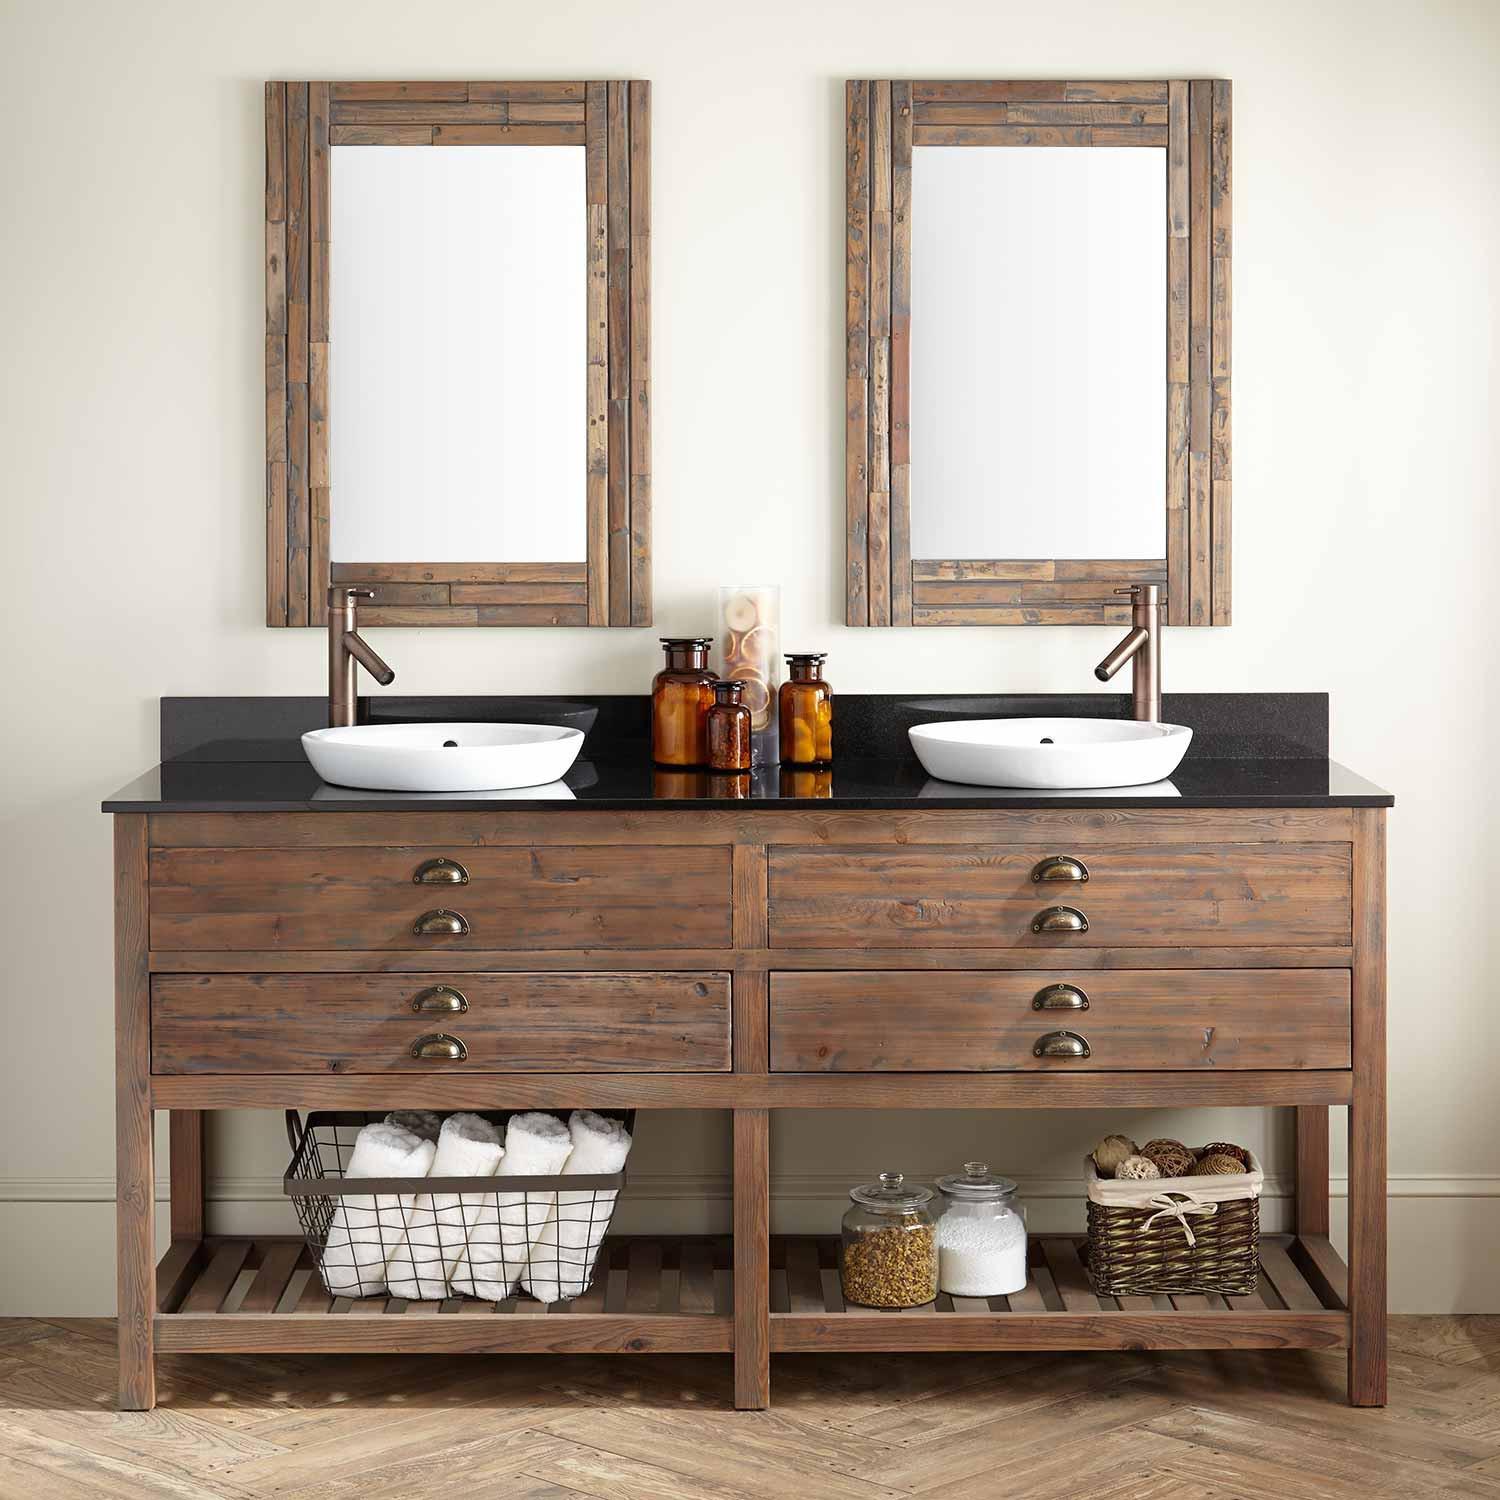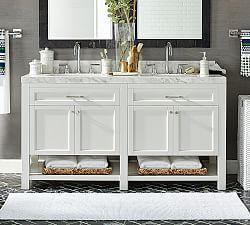The first image is the image on the left, the second image is the image on the right. Analyze the images presented: Is the assertion "The right image shows a vanity with two gooseneck type faucets that curve downward." valid? Answer yes or no. Yes. 